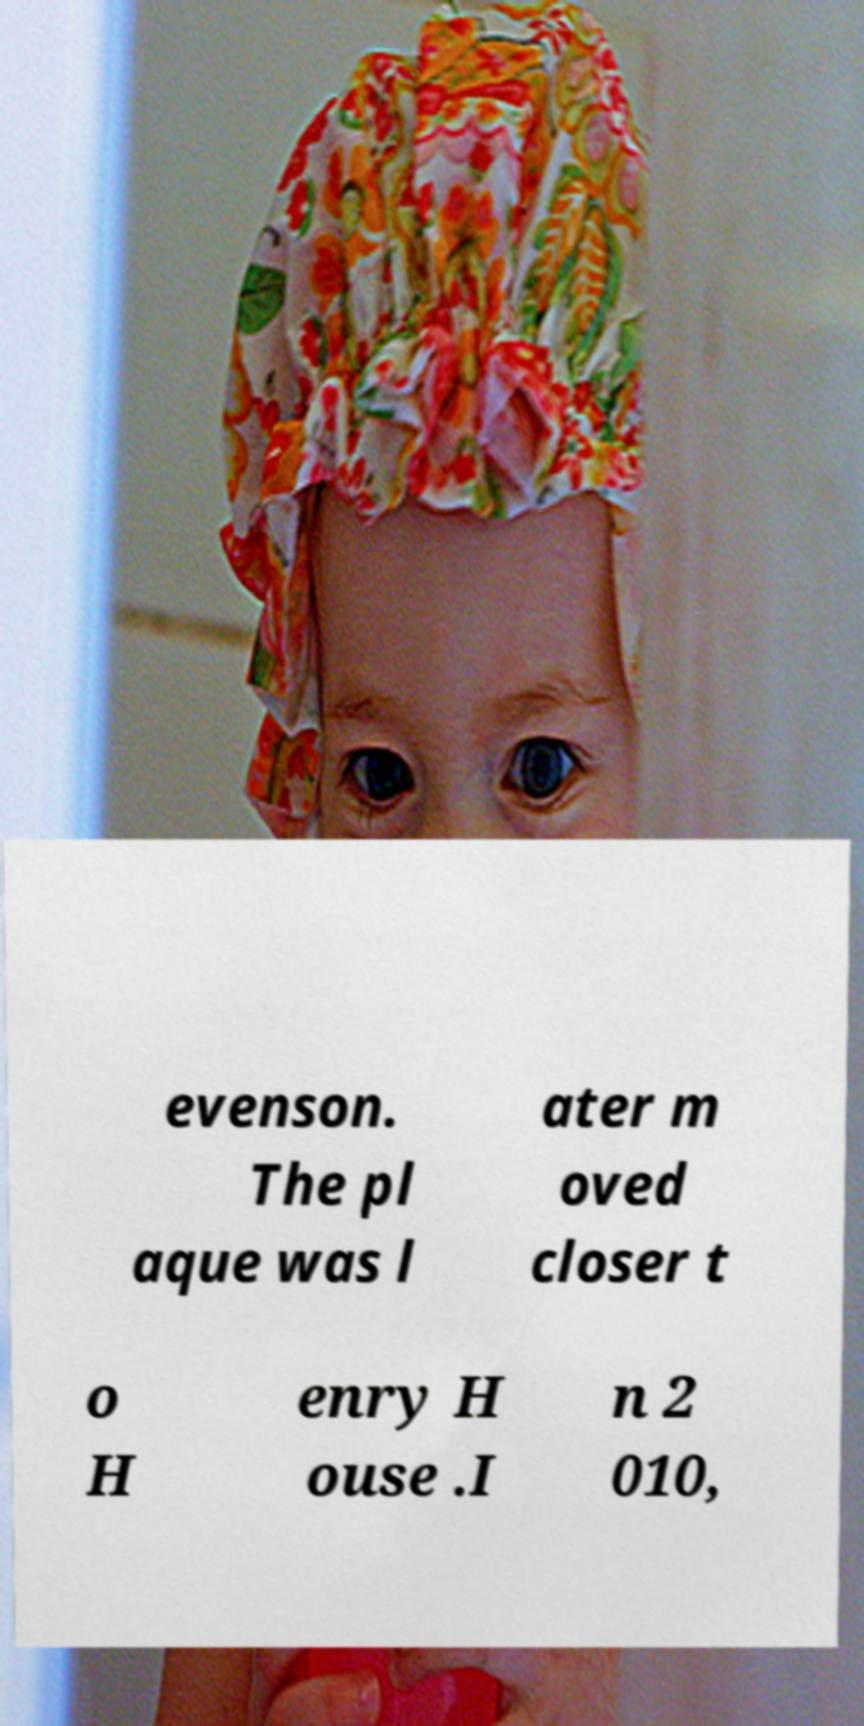Can you accurately transcribe the text from the provided image for me? evenson. The pl aque was l ater m oved closer t o H enry H ouse .I n 2 010, 